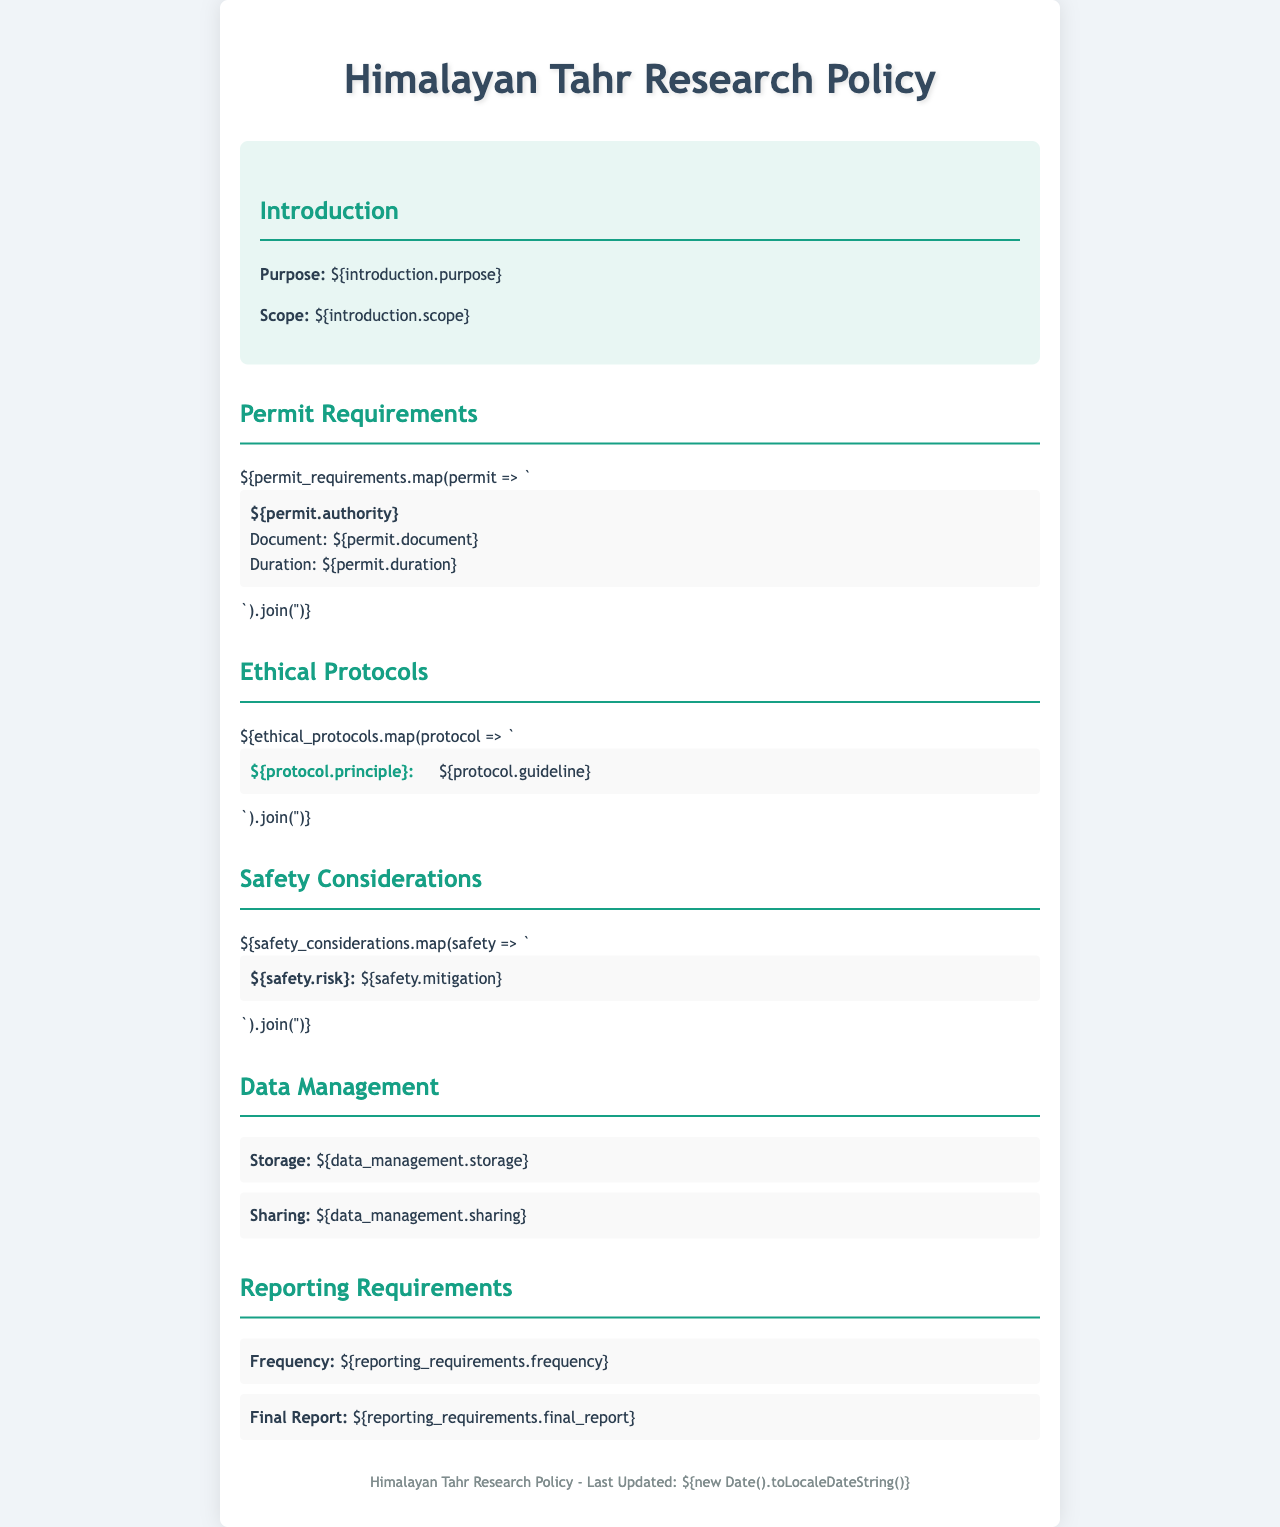what is the purpose of the research policy? The purpose is clearly defined in the introduction section of the document.
Answer: Purpose: ${introduction.purpose} who is responsible for issuing research permits? The authority is specified under the permit requirements section.
Answer: Authority: ${permit_requirements[0].authority} what is the document type required for permits? The required document type is listed in the permit requirements section of the policy.
Answer: Document: ${permit_requirements[0].document} how long is the duration of the research permit? The duration is provided in the same section discussing permit requirements.
Answer: Duration: ${permit_requirements[0].duration} what is the frequency of reporting requirements? The frequency is mentioned under the reporting requirements section.
Answer: Frequency: ${reporting_requirements.frequency} which principle is emphasized in the ethical protocols? Ethical protocols list several principles that guide research conduct.
Answer: Principle: ${ethical_protocols[0].principle} what is one of the safety risks noted in the document? Safety risks are highlighted in the safety considerations section of the policy.
Answer: Risk: ${safety_considerations[0].risk} what is the approach to data sharing outlined in the document? The data management section covers strategies for sharing collected data.
Answer: Sharing: ${data_management.sharing} when was the policy last updated? The last updated date is mentioned in the footer of the document.
Answer: Last Updated: ${new Date().toLocaleDateString()} 